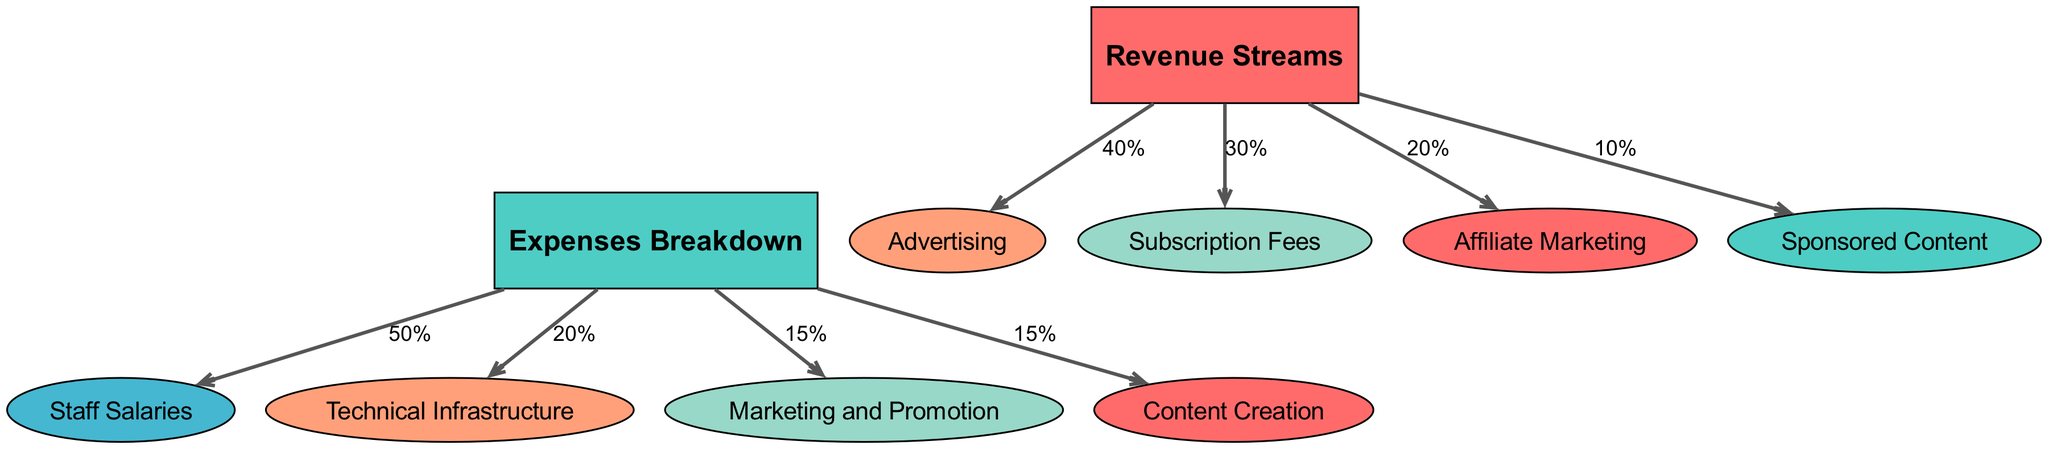What are the main revenue streams listed in the diagram? The diagram includes four main revenue streams: Advertising, Subscription Fees, Affiliate Marketing, and Sponsored Content. These are all explicitly labeled nodes branching from the central "Revenue Streams" node.
Answer: Advertising, Subscription Fees, Affiliate Marketing, Sponsored Content What percentage of revenue comes from Subscription Fees? The edge connecting the "Revenue Streams" node to the "Subscription Fees" node is labeled with "30%". This indicates that Subscription Fees account for 30% of the total revenue.
Answer: 30% How many expense categories are detailed in the diagram? The diagram lists four expense categories: Staff Salaries, Technical Infrastructure, Marketing and Promotion, and Content Creation. Each category is connected to the "Expenses Breakdown" node. Hence, there are four expense categories in total.
Answer: 4 What is the largest expense category based on the edges? The edge leading from "Expenses Breakdown" to "Staff Salaries" is labeled "50%". This indicates that Staff Salaries is the largest expense category in the diagram.
Answer: Staff Salaries What is the combined percentage of revenue from Affiliate Marketing and Sponsored Content? Affiliate Marketing contributes "20%" and Sponsored Content contributes "10%" to the revenue. Adding these two percentages together gives a total of 30%.
Answer: 30% What percentage of expenses is allocated to Technical Infrastructure? The edge from "Expenses Breakdown" to "Technical Infrastructure" is labeled "20%", indicating that this is the percentage of total expenses allocated to this category.
Answer: 20% Which revenue source has the lowest contribution? Upon examining the diagram, the edge leading to "Sponsored Content" is labeled with the lowest percentage of "10%". This indicates that Sponsored Content contributes the least to the revenue streams.
Answer: Sponsored Content What is the total percentage of expenses accounted for by Marketing and Promotion and Content Creation combined? The individual percentages for Marketing and Promotion and Content Creation are both labeled "15%". Adding these amounts together results in a total of 30%.
Answer: 30% 